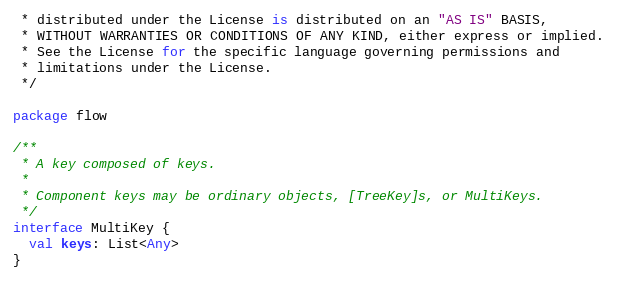Convert code to text. <code><loc_0><loc_0><loc_500><loc_500><_Kotlin_> * distributed under the License is distributed on an "AS IS" BASIS,
 * WITHOUT WARRANTIES OR CONDITIONS OF ANY KIND, either express or implied.
 * See the License for the specific language governing permissions and
 * limitations under the License.
 */

package flow

/**
 * A key composed of keys.
 *
 * Component keys may be ordinary objects, [TreeKey]s, or MultiKeys.
 */
interface MultiKey {
  val keys: List<Any>
}</code> 